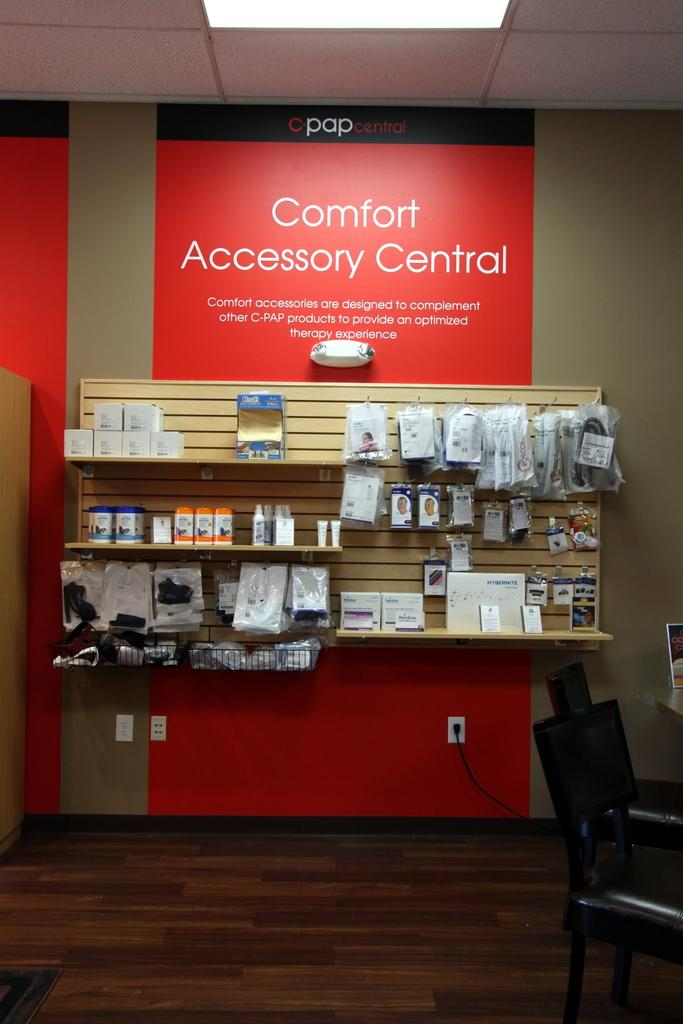<image>
Render a clear and concise summary of the photo. A cell phone store has a red sign that says Comfort Accessory Central. 